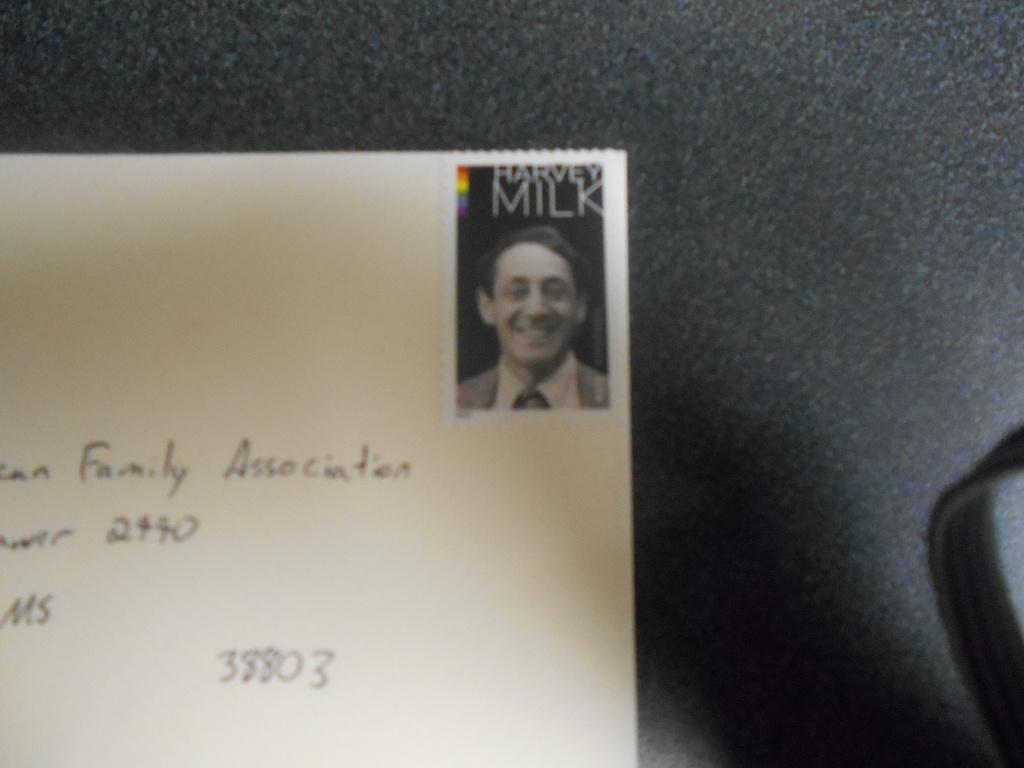Please provide a concise description of this image. In this picture we can see a card, on this card we can see a person and some text on it and this card is placed on a platform. 